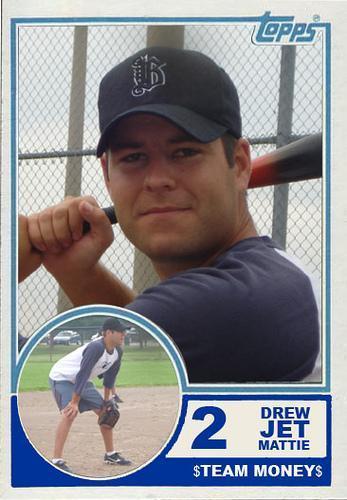How many people can be seen?
Give a very brief answer. 2. 